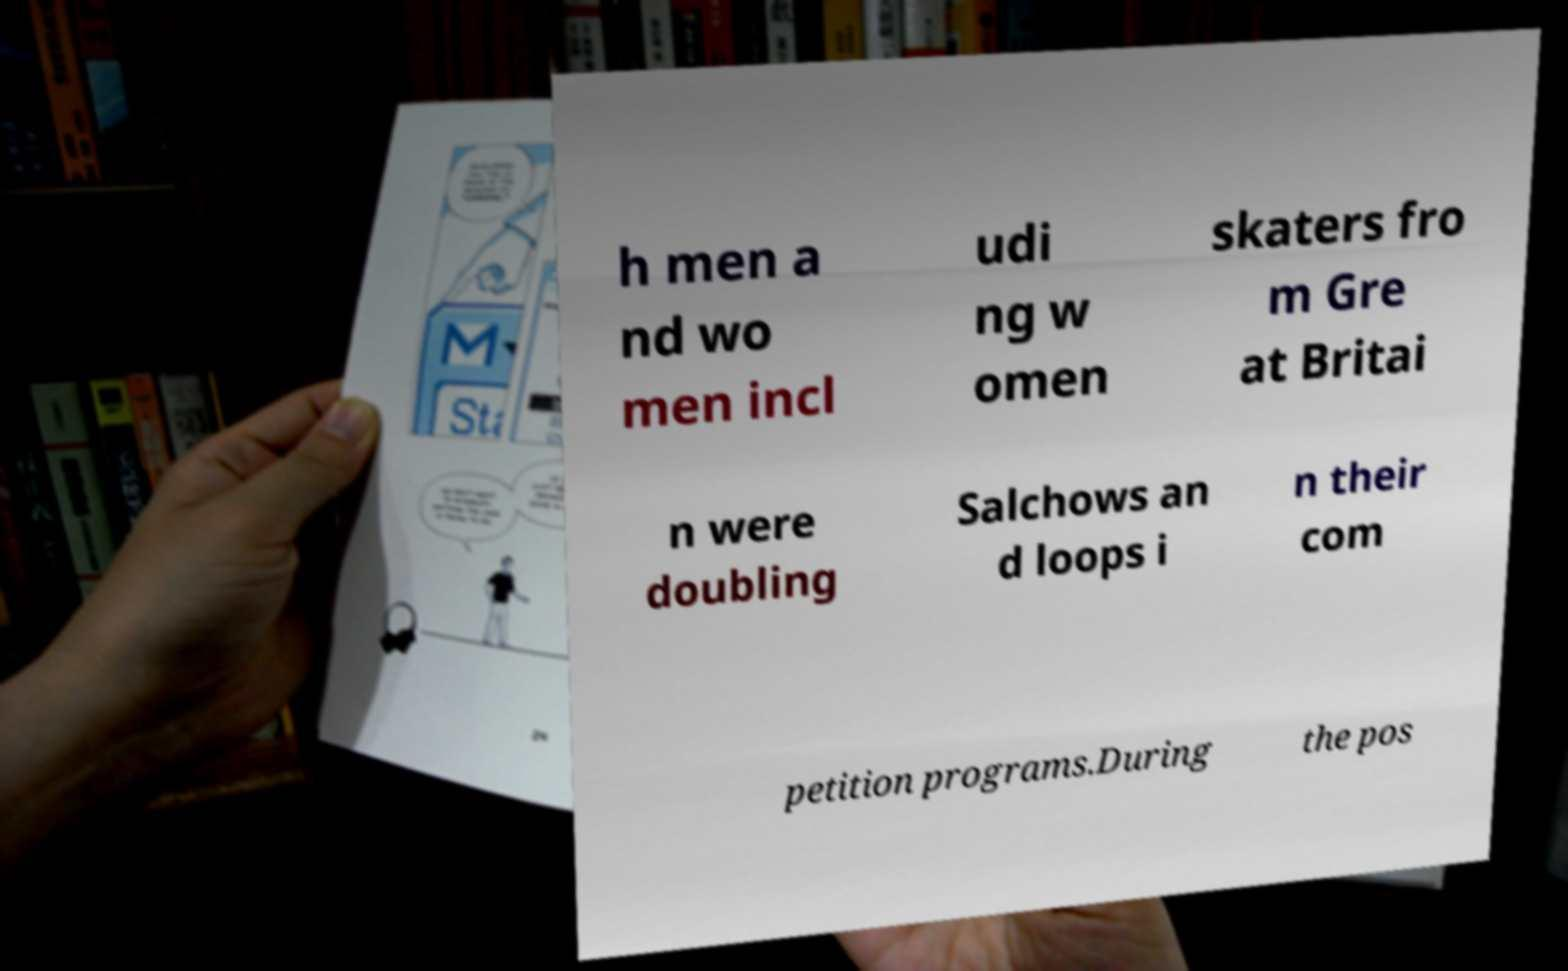I need the written content from this picture converted into text. Can you do that? h men a nd wo men incl udi ng w omen skaters fro m Gre at Britai n were doubling Salchows an d loops i n their com petition programs.During the pos 